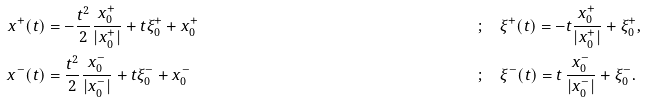Convert formula to latex. <formula><loc_0><loc_0><loc_500><loc_500>x ^ { + } ( t ) & = - \frac { t ^ { 2 } } { 2 } \frac { x _ { 0 } ^ { + } } { | x _ { 0 } ^ { + } | } + t \xi _ { 0 } ^ { + } + x _ { 0 } ^ { + } & & ; \quad \xi ^ { + } ( t ) = - t \frac { x _ { 0 } ^ { + } } { | x _ { 0 } ^ { + } | } + \xi _ { 0 } ^ { + } , \\ x ^ { - } ( t ) & = \frac { t ^ { 2 } } { 2 } \frac { x _ { 0 } ^ { - } } { | x _ { 0 } ^ { - } | } + t \xi _ { 0 } ^ { - } + x _ { 0 } ^ { - } & & ; \quad \xi ^ { - } ( t ) = t \, \frac { x _ { 0 } ^ { - } } { | x _ { 0 } ^ { - } | } + \xi _ { 0 } ^ { - } .</formula> 